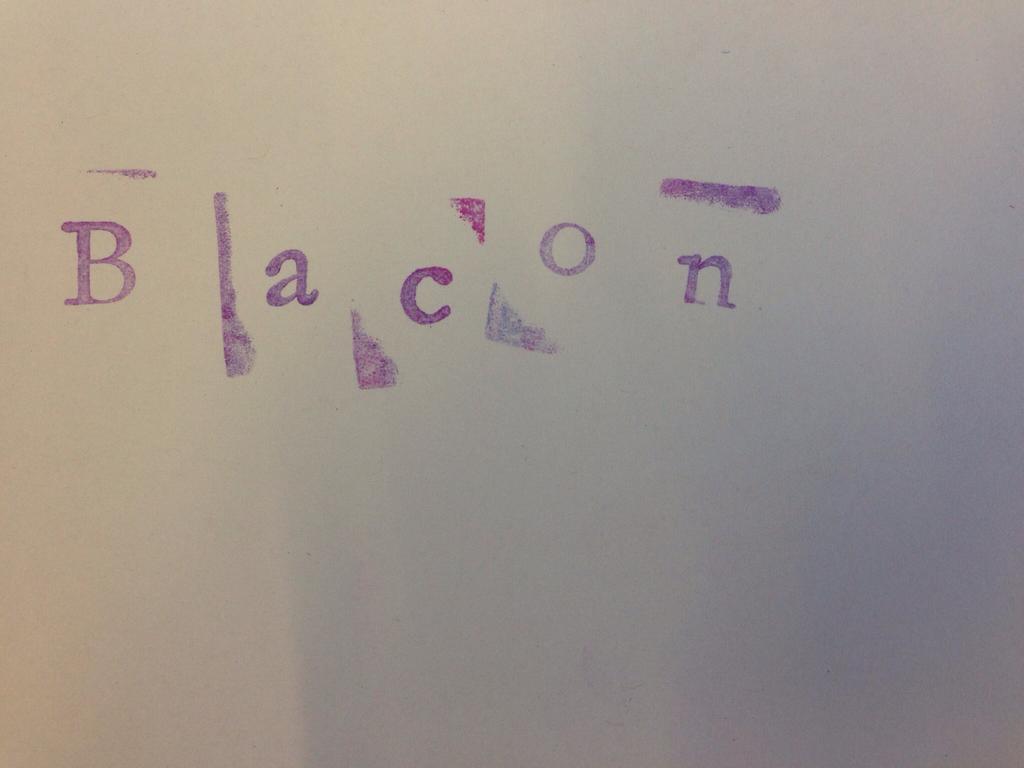What word is written here?
Your response must be concise. Bacon. 